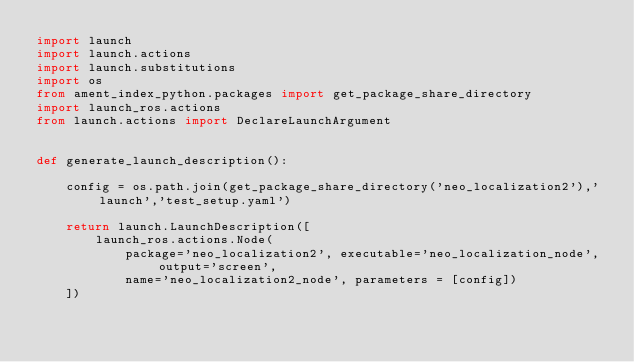Convert code to text. <code><loc_0><loc_0><loc_500><loc_500><_Python_>import launch
import launch.actions
import launch.substitutions
import os
from ament_index_python.packages import get_package_share_directory
import launch_ros.actions
from launch.actions import DeclareLaunchArgument


def generate_launch_description():

    config = os.path.join(get_package_share_directory('neo_localization2'),'launch','test_setup.yaml')

    return launch.LaunchDescription([
        launch_ros.actions.Node(
            package='neo_localization2', executable='neo_localization_node', output='screen',
            name='neo_localization2_node', parameters = [config])
    ])</code> 